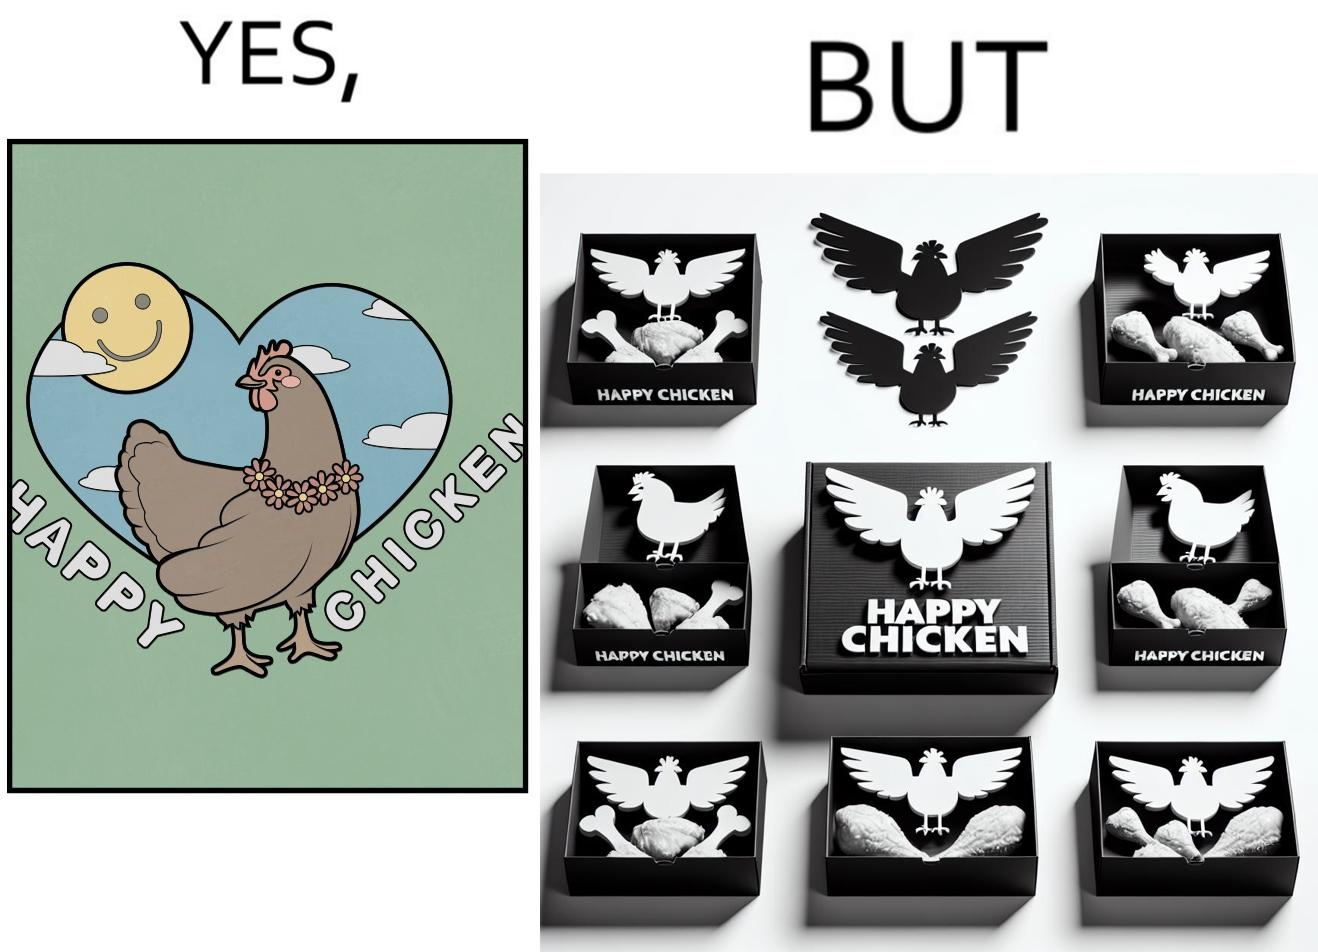Why is this image considered satirical? The image is ironic, because in the left image as in the logo it shows happy chicken but in the right image the chicken pieces are shown packed in boxes 